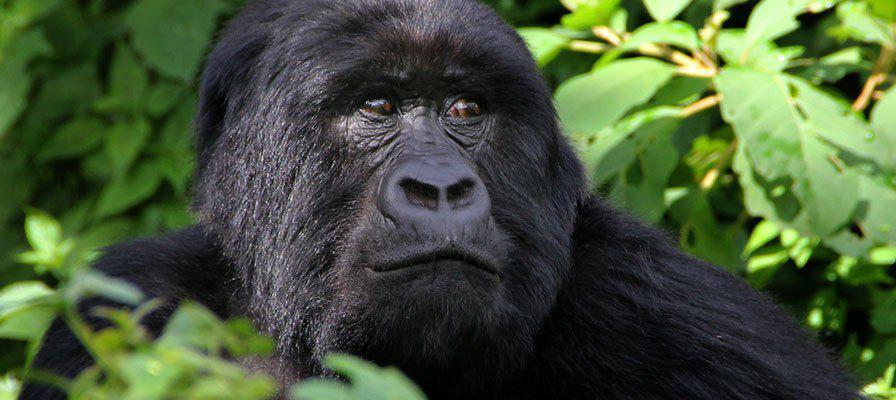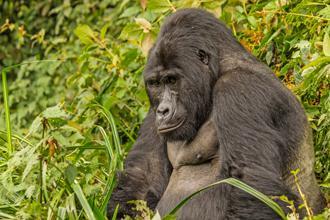The first image is the image on the left, the second image is the image on the right. Analyze the images presented: Is the assertion "A person holding a camera is near an adult gorilla in the left image." valid? Answer yes or no. No. The first image is the image on the left, the second image is the image on the right. Given the left and right images, does the statement "The left image contains a human interacting with a gorilla." hold true? Answer yes or no. No. 